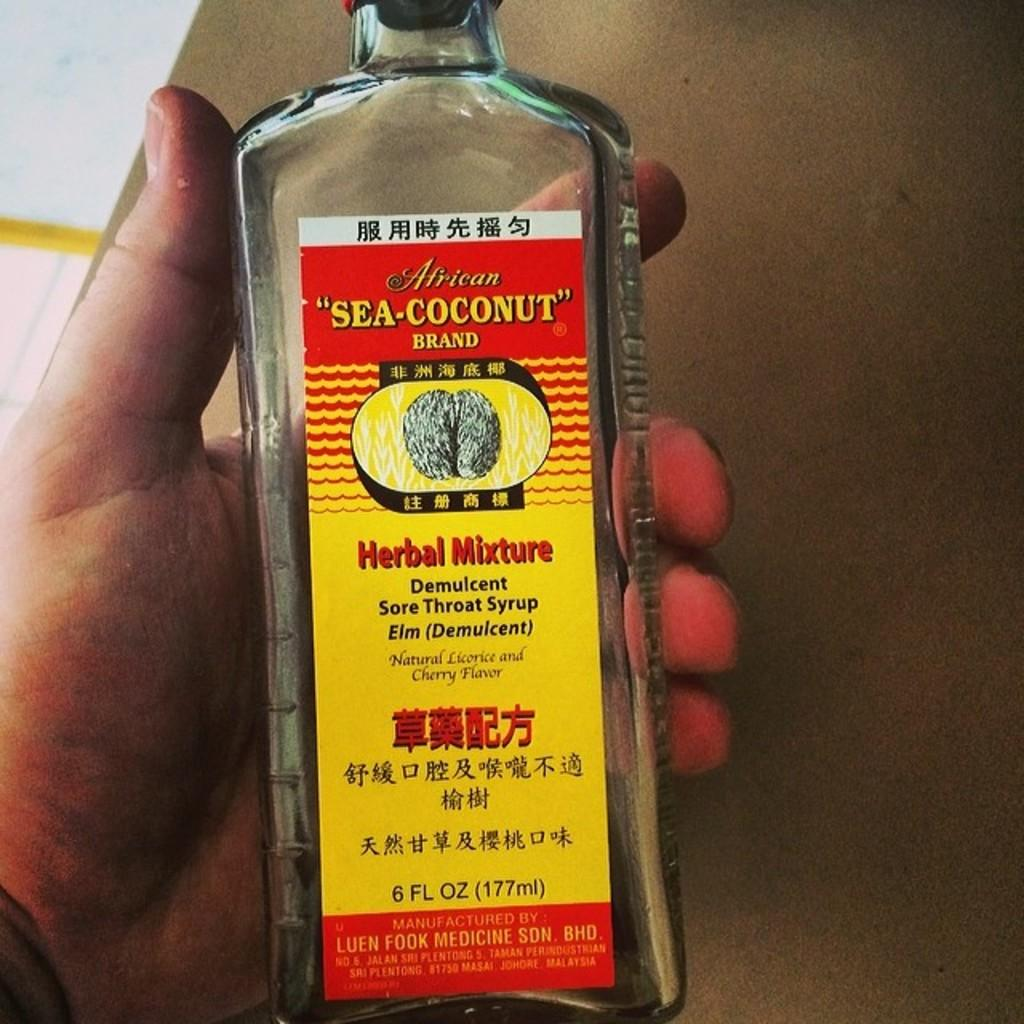<image>
Give a short and clear explanation of the subsequent image. A bottle of Sea Coconut herbal mixture is held in a hand 